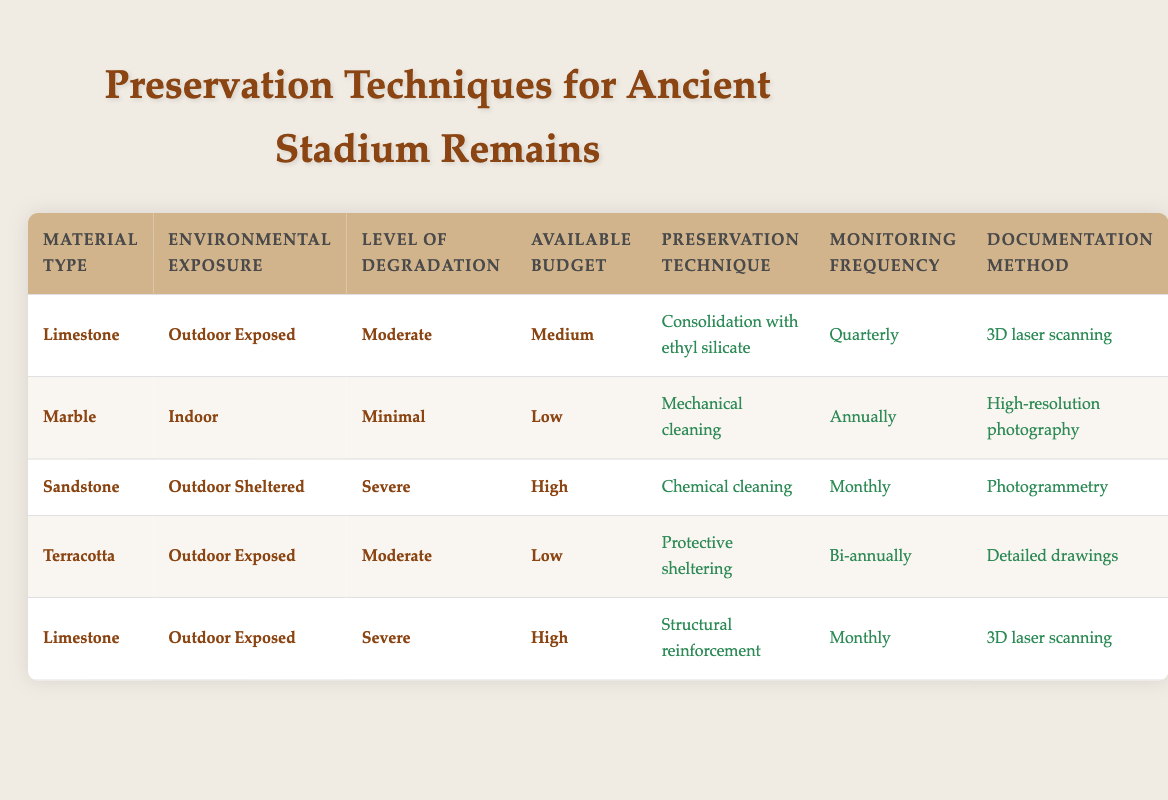What preservation technique is recommended for Limestone with Moderate degradation and a Medium budget in Outdoor Exposed conditions? The table shows that for Limestone as the material type, Outdoor Exposed environmental exposure, Moderate level of degradation, and Medium budget, the recommended preservation technique is "Consolidation with ethyl silicate."
Answer: Consolidation with ethyl silicate What is the monitoring frequency for preserving Terracotta with Moderate degradation in Outdoor Exposed conditions and a Low budget? According to the table, for Terracotta under Outdoor Exposed conditions, with Moderate degradation and a Low budget, the monitoring frequency is "Bi-annually."
Answer: Bi-annually Is Chemical cleaning suggested for Sandstone in Outdoor Sheltered conditions with Severe degradation? Yes, the table indicates that Chemical cleaning is proposed for Sandstone when the environmental exposure is Outdoor Sheltered with a Severe level of degradation and a High budget.
Answer: Yes What are the documentation methods when using Structural reinforcement for Limestone with Severe degradation and a High budget in Outdoor Exposed conditions? The table reveals that for Limestone with Severe degradation, a High budget, and Outdoor Exposed conditions, the documentation method is "3D laser scanning."
Answer: 3D laser scanning How many preservation techniques are available for materials exposed to Outdoor conditions? There are two materials listed under Outdoor conditions: Limestone and Terracotta. Both have unique preservation techniques. Limestone has "Consolidation with ethyl silicate" and "Structural reinforcement," while Terracotta has "Protective sheltering." Therefore, there are three distinct preservation techniques across these materials.
Answer: Three techniques What level of degradation is Marble recommended to have for Mechanical cleaning to be applied under Indoor conditions and a Low budget? The table specifies that Marble should have a Minimal level of degradation to apply Mechanical cleaning under Indoor conditions with a Low budget.
Answer: Minimal If the budget was increased to High for Sandstone preservation, what monitoring frequency changes would occur? The table shows that if the budget for Sandstone is High, with Severe degradation and Outdoor Sheltered exposure, the monitoring frequency is set to "Monthly," which is more frequent than the other budgets.
Answer: Monthly Is there a difference in preservation techniques for Limestone with Moderate degradation between Outdoor Exposed and Outdoor Sheltered conditions? The table does not provide data for Limestone in Outdoor Sheltered conditions, but for Outdoor Exposed with Moderate degradation, the preservation technique is "Consolidation with ethyl silicate." Thus, a comparison can't be made due to lack of information.
Answer: Yes, no comparison due to lack of data 